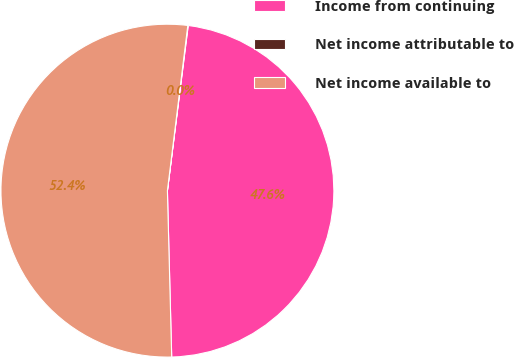<chart> <loc_0><loc_0><loc_500><loc_500><pie_chart><fcel>Income from continuing<fcel>Net income attributable to<fcel>Net income available to<nl><fcel>47.59%<fcel>0.04%<fcel>52.36%<nl></chart> 